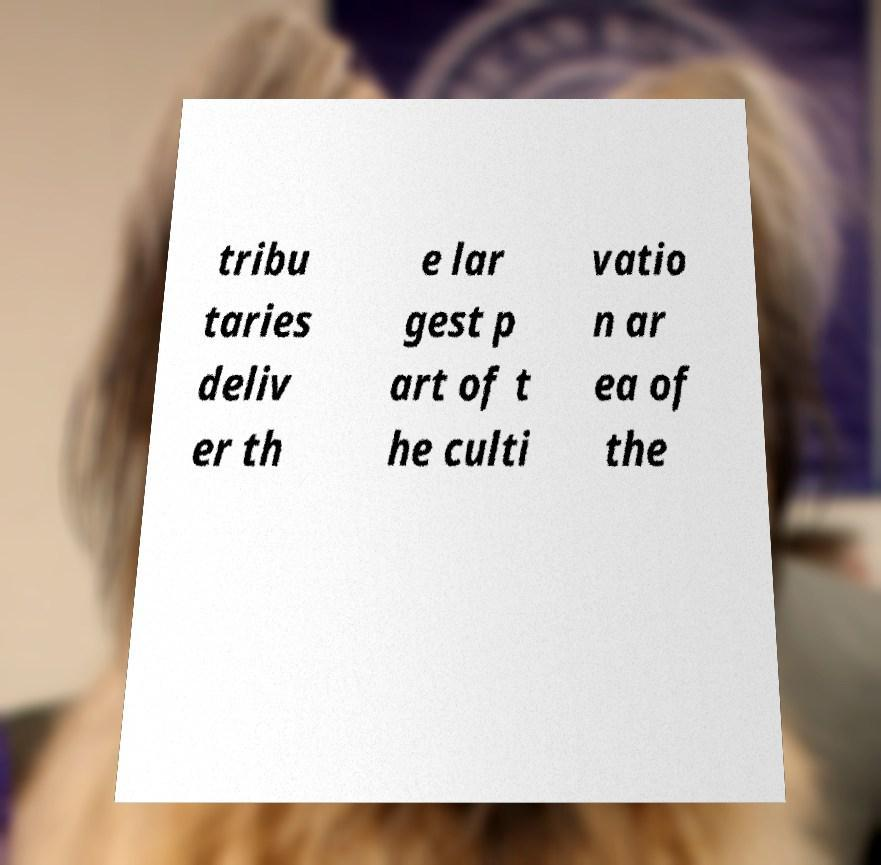What messages or text are displayed in this image? I need them in a readable, typed format. tribu taries deliv er th e lar gest p art of t he culti vatio n ar ea of the 